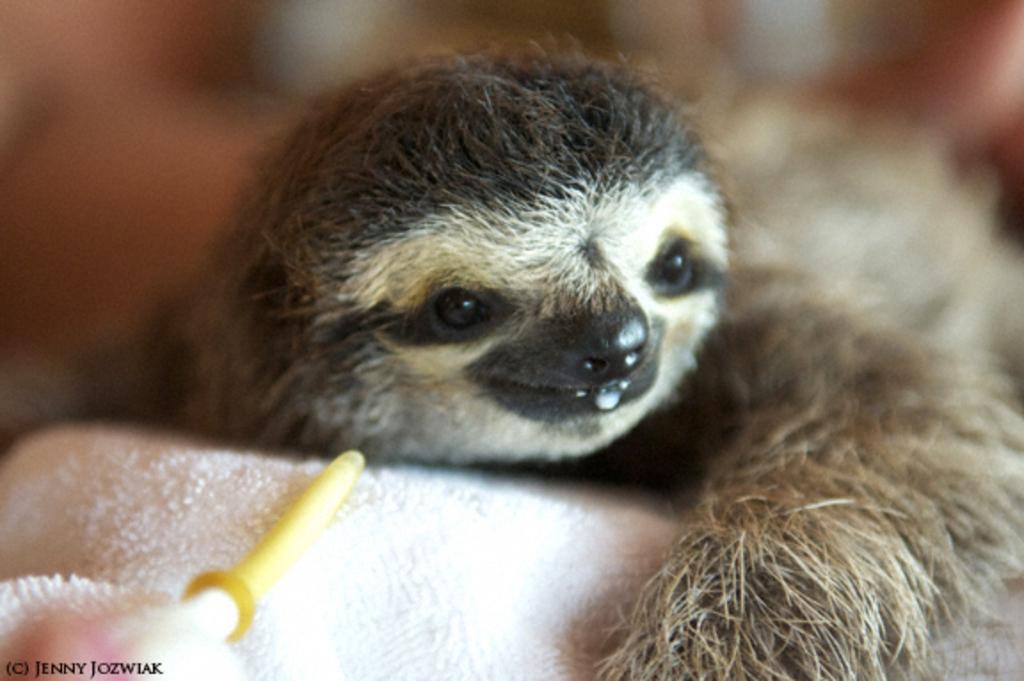Can you describe this image briefly? In this image I can see a sloth on a white cloth. The background is blurred. 